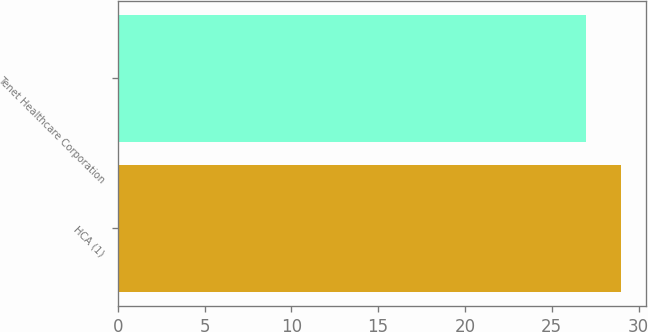Convert chart to OTSL. <chart><loc_0><loc_0><loc_500><loc_500><bar_chart><fcel>HCA (1)<fcel>Tenet Healthcare Corporation<nl><fcel>29<fcel>27<nl></chart> 